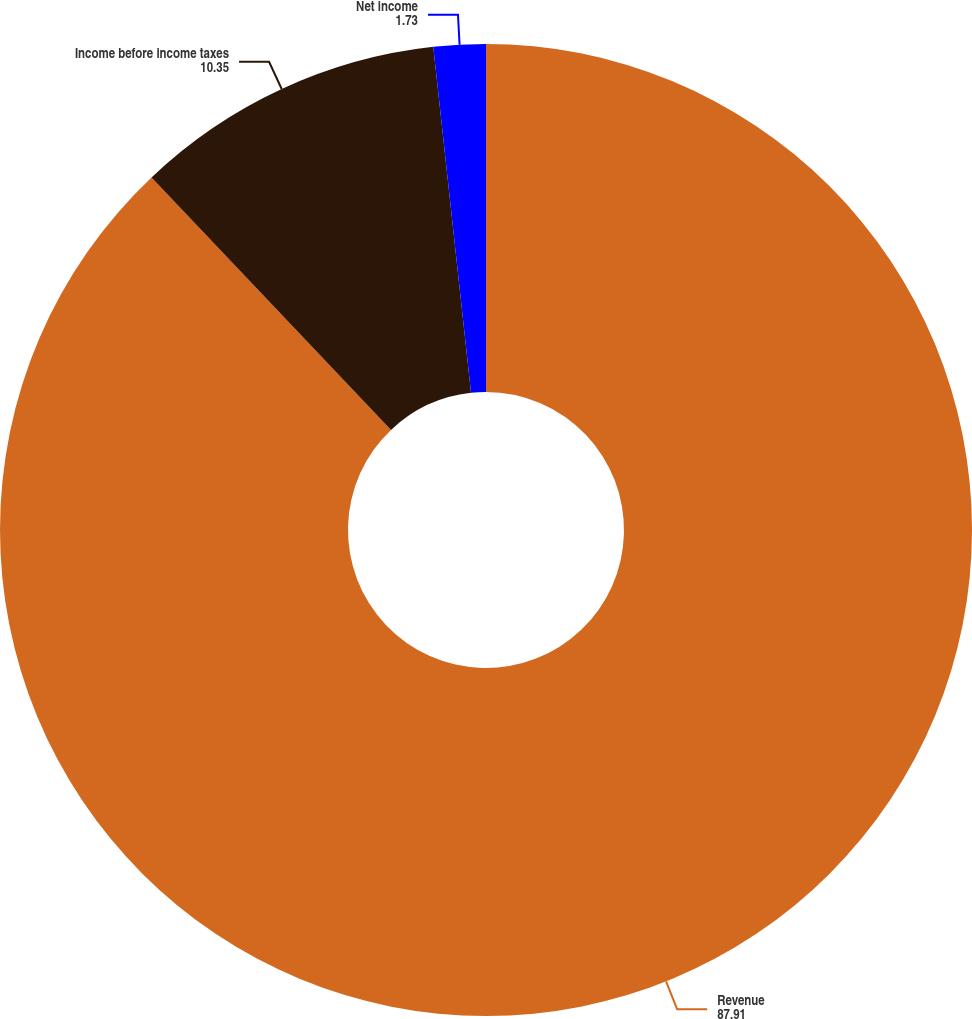Convert chart. <chart><loc_0><loc_0><loc_500><loc_500><pie_chart><fcel>Revenue<fcel>Income before income taxes<fcel>Net income<nl><fcel>87.91%<fcel>10.35%<fcel>1.73%<nl></chart> 